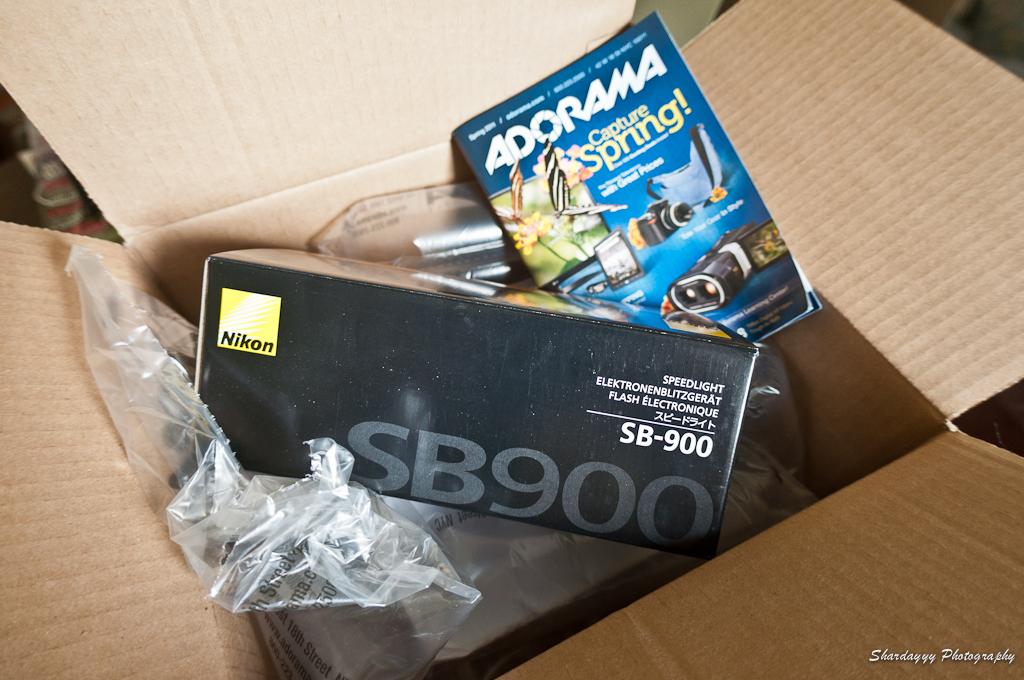What brand of camera was in the box?
Your answer should be very brief. Nikon. What number is on the box?
Make the answer very short. 900. 